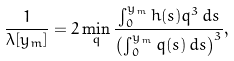Convert formula to latex. <formula><loc_0><loc_0><loc_500><loc_500>\frac { 1 } { \lambda [ y _ { m } ] } = 2 \min _ { q } \frac { \int _ { 0 } ^ { y _ { m } } h ( s ) q ^ { 3 } \, d s } { \left ( \int _ { 0 } ^ { y _ { m } } q ( s ) \, d s \right ) ^ { 3 } } ,</formula> 